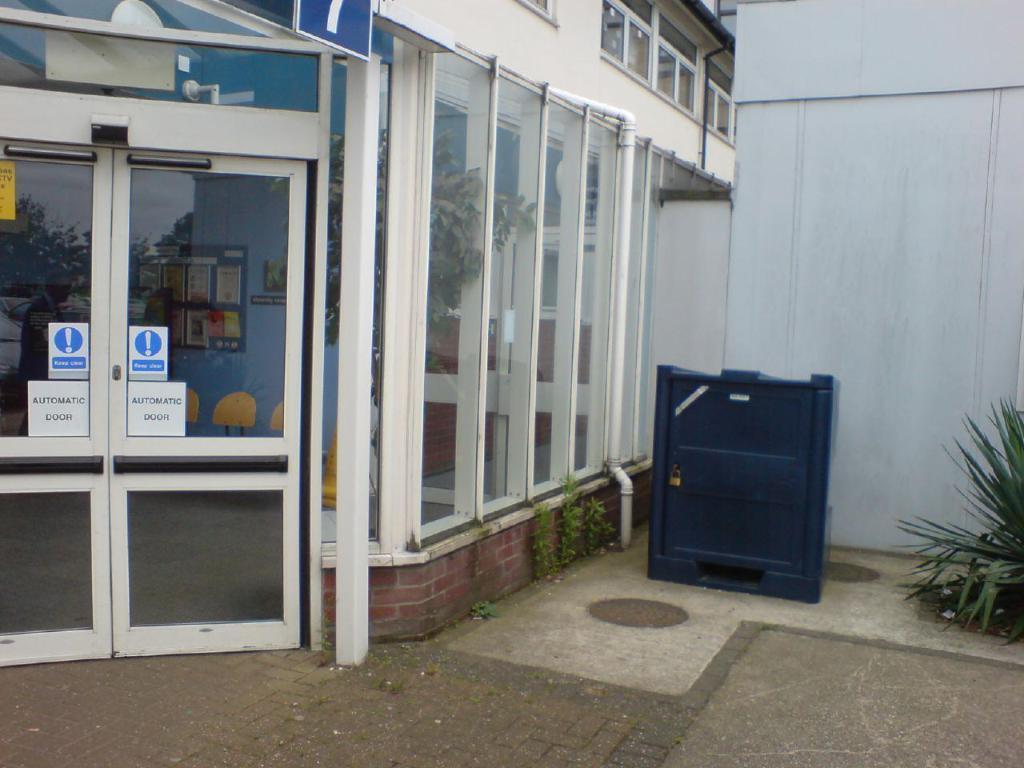Could you give a brief overview of what you see in this image? In this image we can see glass doors, plants, a wall and a metal object. 